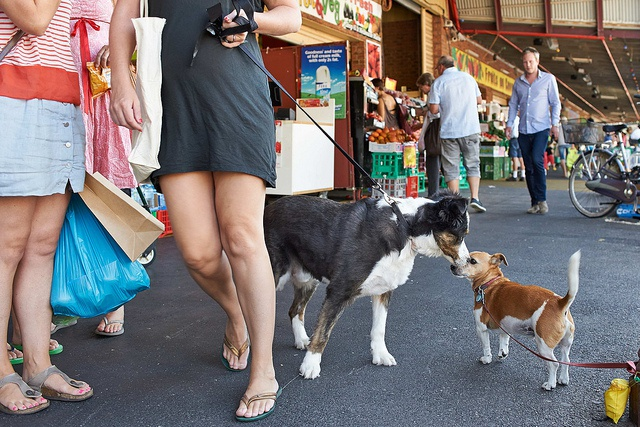Describe the objects in this image and their specific colors. I can see people in brown, black, tan, and gray tones, people in brown, tan, lightgray, lightblue, and salmon tones, dog in brown, black, gray, lightgray, and darkgray tones, dog in brown, maroon, darkgray, gray, and lightgray tones, and people in brown, lavender, lightpink, and pink tones in this image. 